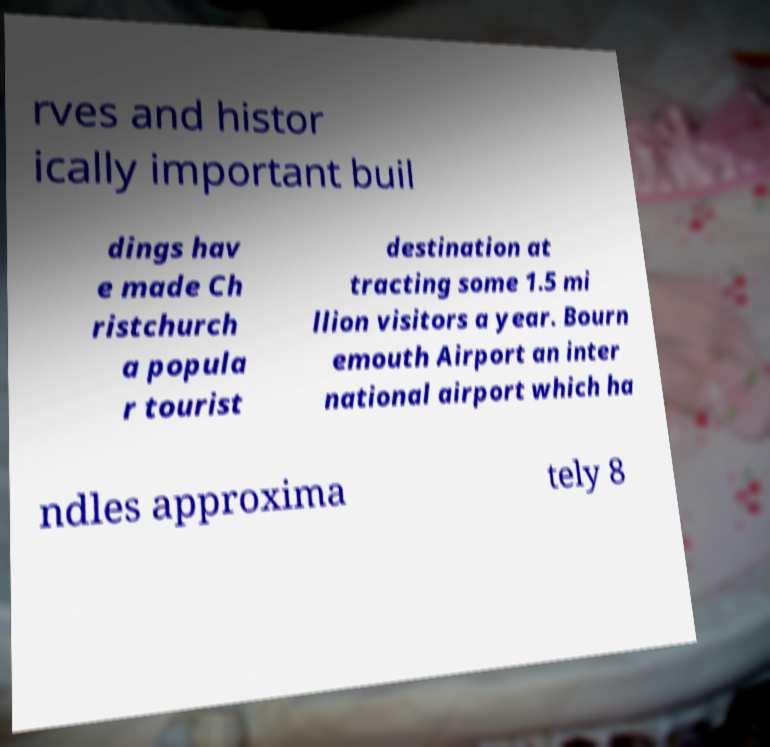Can you accurately transcribe the text from the provided image for me? rves and histor ically important buil dings hav e made Ch ristchurch a popula r tourist destination at tracting some 1.5 mi llion visitors a year. Bourn emouth Airport an inter national airport which ha ndles approxima tely 8 